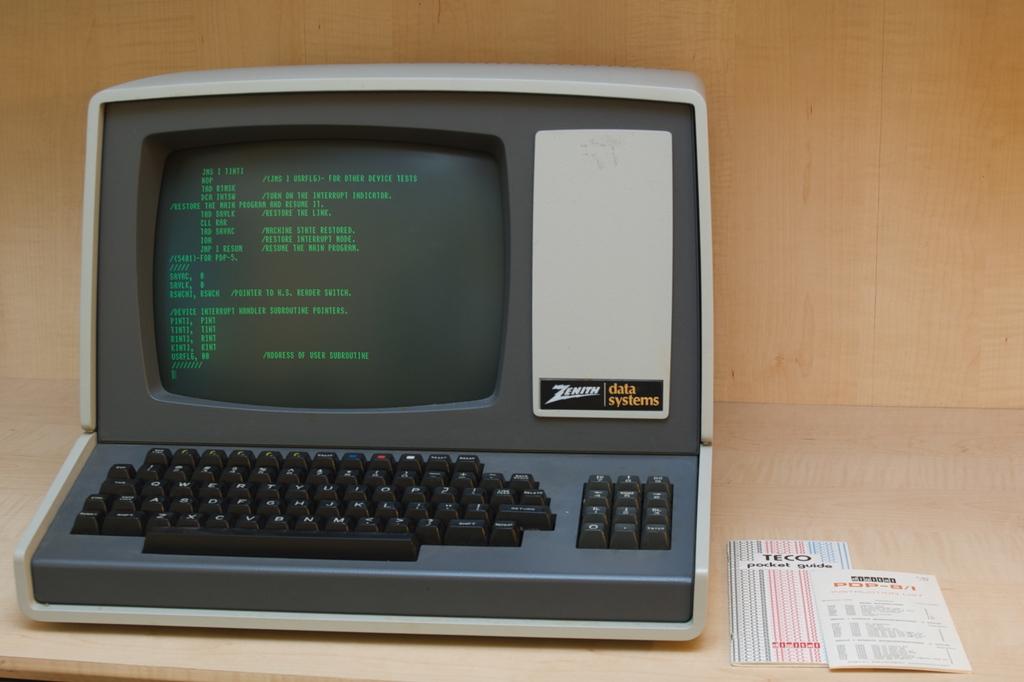What data system is mentioned on the computer?
Give a very brief answer. Zenith. What is the brand of the pocket guide?
Provide a short and direct response. Teco. 